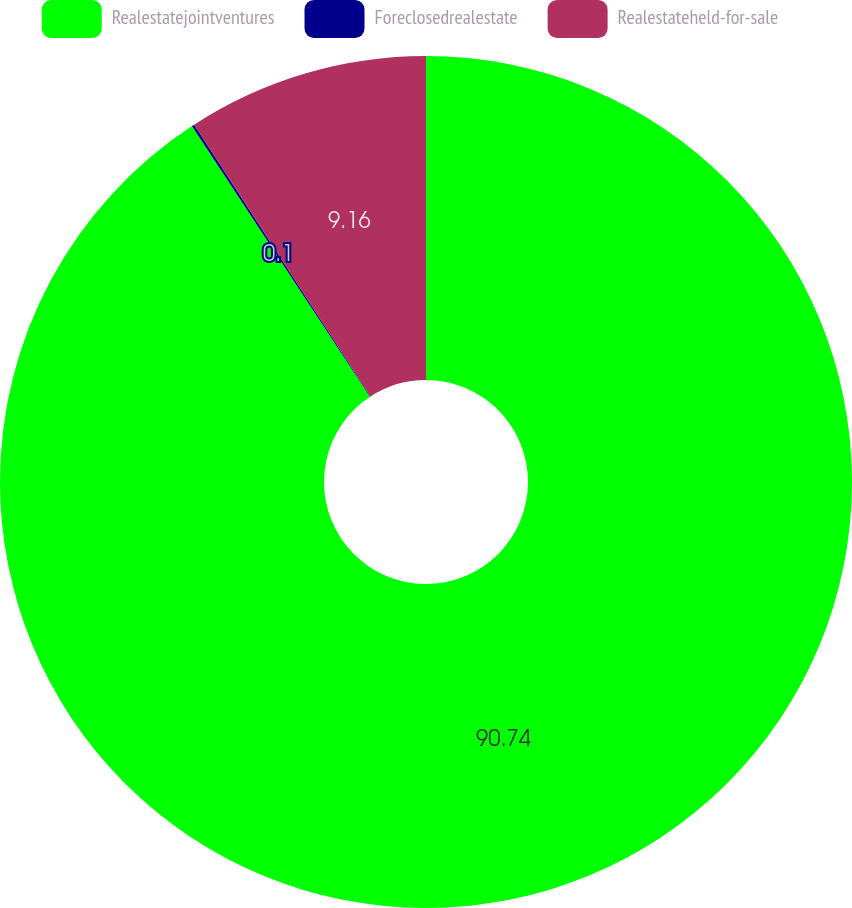Convert chart. <chart><loc_0><loc_0><loc_500><loc_500><pie_chart><fcel>Realestatejointventures<fcel>Foreclosedrealestate<fcel>Realestateheld-for-sale<nl><fcel>90.74%<fcel>0.1%<fcel>9.16%<nl></chart> 